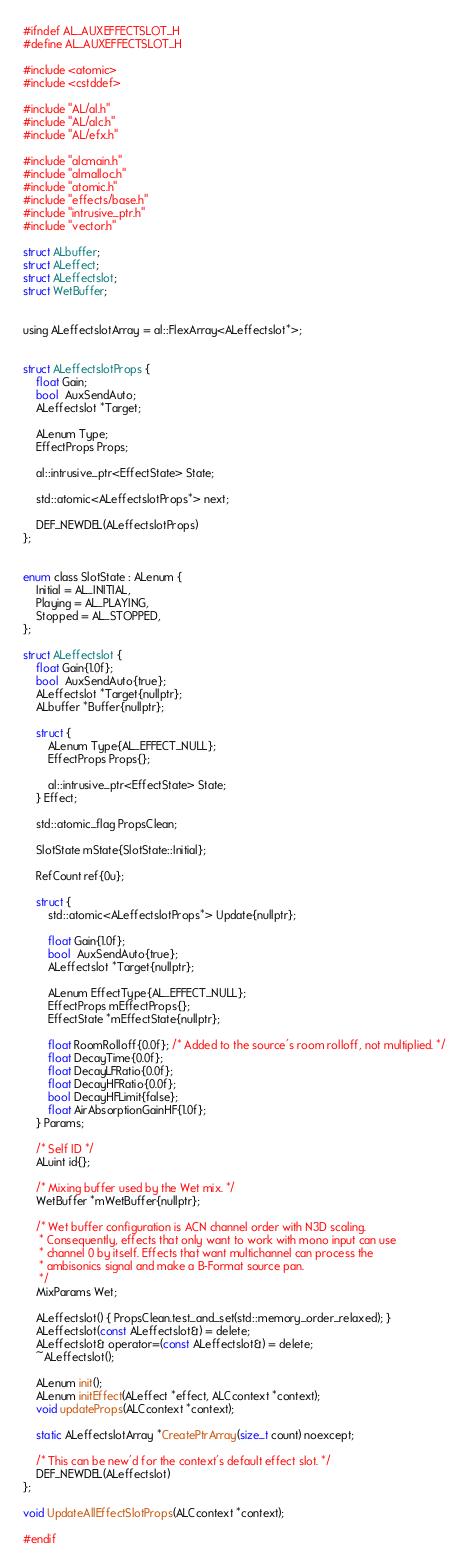<code> <loc_0><loc_0><loc_500><loc_500><_C_>#ifndef AL_AUXEFFECTSLOT_H
#define AL_AUXEFFECTSLOT_H

#include <atomic>
#include <cstddef>

#include "AL/al.h"
#include "AL/alc.h"
#include "AL/efx.h"

#include "alcmain.h"
#include "almalloc.h"
#include "atomic.h"
#include "effects/base.h"
#include "intrusive_ptr.h"
#include "vector.h"

struct ALbuffer;
struct ALeffect;
struct ALeffectslot;
struct WetBuffer;


using ALeffectslotArray = al::FlexArray<ALeffectslot*>;


struct ALeffectslotProps {
    float Gain;
    bool  AuxSendAuto;
    ALeffectslot *Target;

    ALenum Type;
    EffectProps Props;

    al::intrusive_ptr<EffectState> State;

    std::atomic<ALeffectslotProps*> next;

    DEF_NEWDEL(ALeffectslotProps)
};


enum class SlotState : ALenum {
    Initial = AL_INITIAL,
    Playing = AL_PLAYING,
    Stopped = AL_STOPPED,
};

struct ALeffectslot {
    float Gain{1.0f};
    bool  AuxSendAuto{true};
    ALeffectslot *Target{nullptr};
    ALbuffer *Buffer{nullptr};

    struct {
        ALenum Type{AL_EFFECT_NULL};
        EffectProps Props{};

        al::intrusive_ptr<EffectState> State;
    } Effect;

    std::atomic_flag PropsClean;

    SlotState mState{SlotState::Initial};

    RefCount ref{0u};

    struct {
        std::atomic<ALeffectslotProps*> Update{nullptr};

        float Gain{1.0f};
        bool  AuxSendAuto{true};
        ALeffectslot *Target{nullptr};

        ALenum EffectType{AL_EFFECT_NULL};
        EffectProps mEffectProps{};
        EffectState *mEffectState{nullptr};

        float RoomRolloff{0.0f}; /* Added to the source's room rolloff, not multiplied. */
        float DecayTime{0.0f};
        float DecayLFRatio{0.0f};
        float DecayHFRatio{0.0f};
        bool DecayHFLimit{false};
        float AirAbsorptionGainHF{1.0f};
    } Params;

    /* Self ID */
    ALuint id{};

    /* Mixing buffer used by the Wet mix. */
    WetBuffer *mWetBuffer{nullptr};

    /* Wet buffer configuration is ACN channel order with N3D scaling.
     * Consequently, effects that only want to work with mono input can use
     * channel 0 by itself. Effects that want multichannel can process the
     * ambisonics signal and make a B-Format source pan.
     */
    MixParams Wet;

    ALeffectslot() { PropsClean.test_and_set(std::memory_order_relaxed); }
    ALeffectslot(const ALeffectslot&) = delete;
    ALeffectslot& operator=(const ALeffectslot&) = delete;
    ~ALeffectslot();

    ALenum init();
    ALenum initEffect(ALeffect *effect, ALCcontext *context);
    void updateProps(ALCcontext *context);

    static ALeffectslotArray *CreatePtrArray(size_t count) noexcept;

    /* This can be new'd for the context's default effect slot. */
    DEF_NEWDEL(ALeffectslot)
};

void UpdateAllEffectSlotProps(ALCcontext *context);

#endif
</code> 